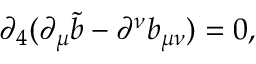Convert formula to latex. <formula><loc_0><loc_0><loc_500><loc_500>\partial _ { 4 } ( \partial _ { \mu } \tilde { b } - \partial ^ { \nu } b _ { \mu \nu } ) = 0 ,</formula> 